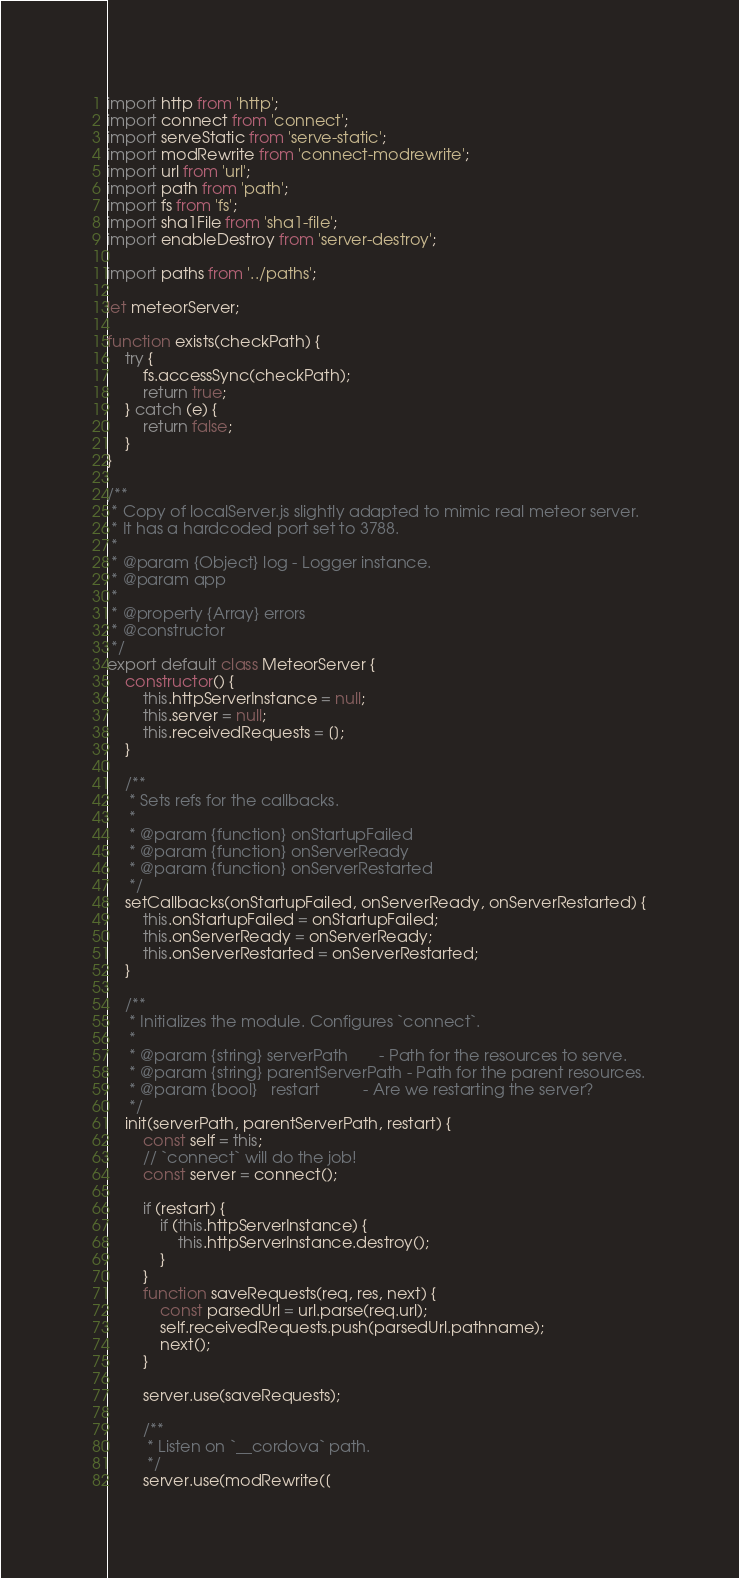Convert code to text. <code><loc_0><loc_0><loc_500><loc_500><_JavaScript_>import http from 'http';
import connect from 'connect';
import serveStatic from 'serve-static';
import modRewrite from 'connect-modrewrite';
import url from 'url';
import path from 'path';
import fs from 'fs';
import sha1File from 'sha1-file';
import enableDestroy from 'server-destroy';

import paths from '../paths';

let meteorServer;

function exists(checkPath) {
    try {
        fs.accessSync(checkPath);
        return true;
    } catch (e) {
        return false;
    }
}

/**
 * Copy of localServer.js slightly adapted to mimic real meteor server.
 * It has a hardcoded port set to 3788.
 *
 * @param {Object} log - Logger instance.
 * @param app
 *
 * @property {Array} errors
 * @constructor
 */
export default class MeteorServer {
    constructor() {
        this.httpServerInstance = null;
        this.server = null;
        this.receivedRequests = [];
    }

    /**
     * Sets refs for the callbacks.
     *
     * @param {function} onStartupFailed
     * @param {function} onServerReady
     * @param {function} onServerRestarted
     */
    setCallbacks(onStartupFailed, onServerReady, onServerRestarted) {
        this.onStartupFailed = onStartupFailed;
        this.onServerReady = onServerReady;
        this.onServerRestarted = onServerRestarted;
    }

    /**
     * Initializes the module. Configures `connect`.
     *
     * @param {string} serverPath       - Path for the resources to serve.
     * @param {string} parentServerPath - Path for the parent resources.
     * @param {bool}   restart          - Are we restarting the server?
     */
    init(serverPath, parentServerPath, restart) {
        const self = this;
        // `connect` will do the job!
        const server = connect();

        if (restart) {
            if (this.httpServerInstance) {
                this.httpServerInstance.destroy();
            }
        }
        function saveRequests(req, res, next) {
            const parsedUrl = url.parse(req.url);
            self.receivedRequests.push(parsedUrl.pathname);
            next();
        }

        server.use(saveRequests);

        /**
         * Listen on `__cordova` path.
         */
        server.use(modRewrite([</code> 